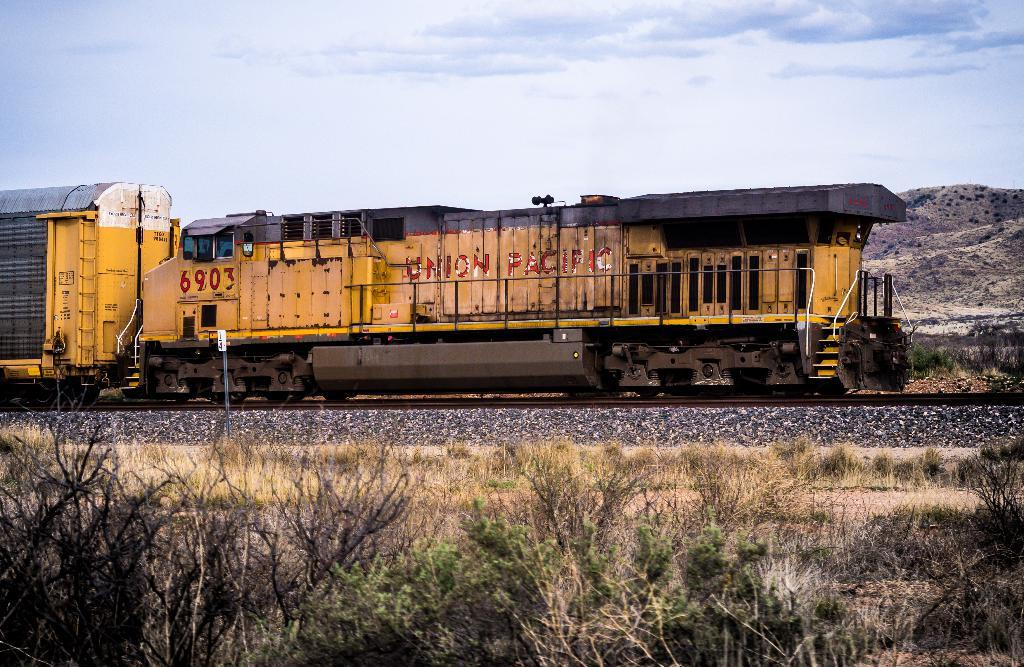What is the main subject of the image? The main subject of the image is a train. Can you describe the train's position in the image? The train is on a track in the image. What type of vegetation can be seen at the bottom of the image? There are plants visible at the bottom of the image. What can be seen in the background of the image? There is a hill and the sky visible in the background of the image. What color is the scarf worn by the train in the image? There is no scarf present in the image, as trains do not wear scarves. 